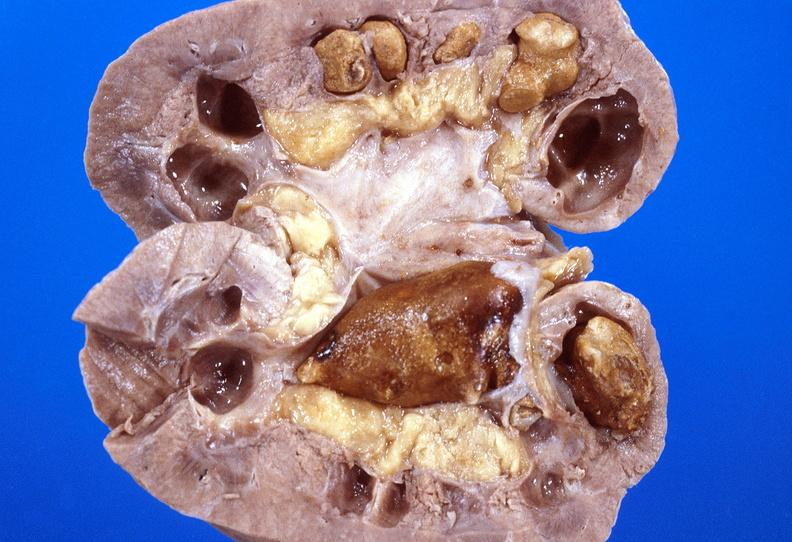does this image show kidney, staghorn calculi?
Answer the question using a single word or phrase. Yes 